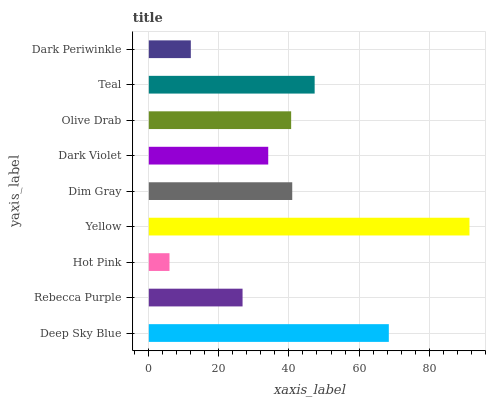Is Hot Pink the minimum?
Answer yes or no. Yes. Is Yellow the maximum?
Answer yes or no. Yes. Is Rebecca Purple the minimum?
Answer yes or no. No. Is Rebecca Purple the maximum?
Answer yes or no. No. Is Deep Sky Blue greater than Rebecca Purple?
Answer yes or no. Yes. Is Rebecca Purple less than Deep Sky Blue?
Answer yes or no. Yes. Is Rebecca Purple greater than Deep Sky Blue?
Answer yes or no. No. Is Deep Sky Blue less than Rebecca Purple?
Answer yes or no. No. Is Olive Drab the high median?
Answer yes or no. Yes. Is Olive Drab the low median?
Answer yes or no. Yes. Is Teal the high median?
Answer yes or no. No. Is Dark Periwinkle the low median?
Answer yes or no. No. 